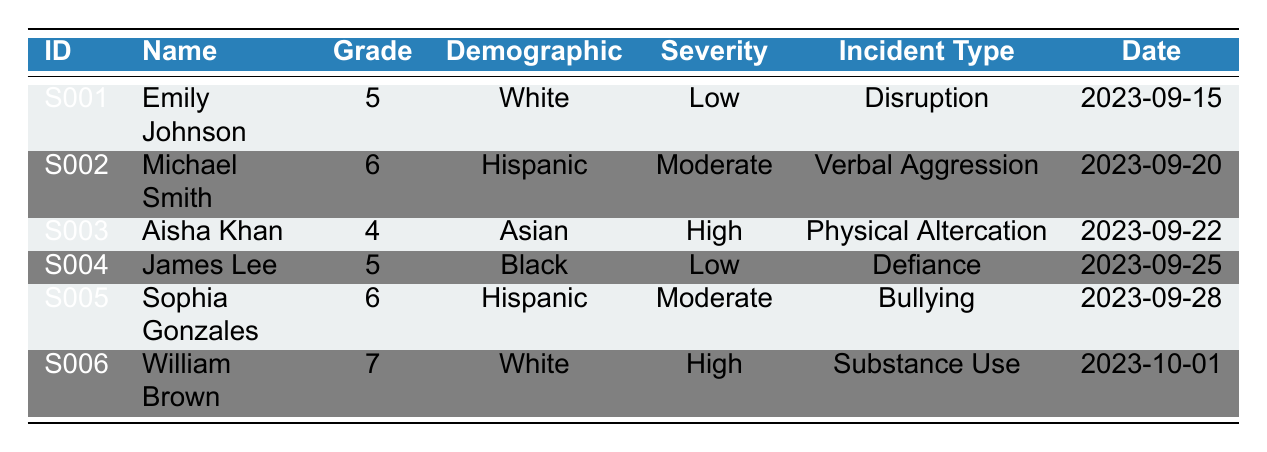What is the most severe incident reported in the table? The table lists incidents categorized by severity. The severity levels are Low, Moderate, and High. Looking through the incidents, "Aisha Khan" has a "High" severity incident.
Answer: High How many students from the Hispanic demographic are represented? The table shows three incidents categorized under the Hispanic demographic group. These incidents are associated with "Michael Smith" and "Sophia Gonzales."
Answer: 2 What is the incident type of the report for William Brown? William Brown's incident record is listed under the "Incident Type" column. Upon checking, it states "Substance Use."
Answer: Substance Use Are there any incidents categorized as "Defiance"? By scanning through the table, I can see that "James Lee" has an incident categorized as "Defiance." Therefore, there is an incident of this type.
Answer: Yes What is the average severity level of incidents reported by Asian students? Only one incident reported by an Asian student is found, which is "Aisha Khan" with a "High" severity level. Since there is only one incident, the average severity level is the same as the single value.
Answer: High How many reports are classified as "Low" severity? The table displays two incidents classified under "Low" severity: those of "Emily Johnson" and "James Lee." Counting these, there are two incidents.
Answer: 2 Which grade had the highest severity incidents? Checking each severity level against grades, "William Brown" (grade 7) and "Aisha Khan" (grade 4) both have high severity incidents. Since grade 7 is higher than grade 4, it is the highest.
Answer: 7 Is there any student with two moderate severity incidents? Scanning through the table reveals that both "Michael Smith" and "Sophia Gonzales" have moderate severity incidents, but no student has two records of such severity.
Answer: No 